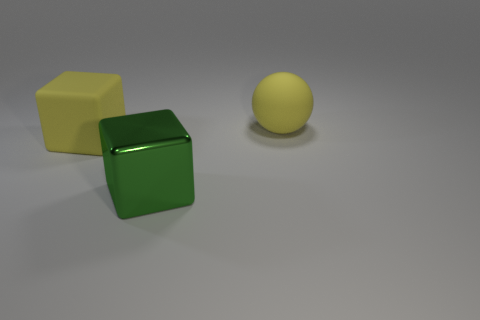There is another object that is the same shape as the green shiny thing; what material is it?
Provide a succinct answer. Rubber. Does the thing that is right of the large green object have the same color as the rubber object in front of the yellow rubber sphere?
Keep it short and to the point. Yes. Is there a metallic block that has the same size as the green shiny thing?
Your answer should be very brief. No. There is a large thing that is to the left of the yellow matte ball and behind the green shiny cube; what is its material?
Give a very brief answer. Rubber. What number of metallic objects are large brown blocks or yellow spheres?
Keep it short and to the point. 0. There is a large yellow object that is made of the same material as the ball; what shape is it?
Ensure brevity in your answer.  Cube. What number of large objects are both on the left side of the large rubber ball and behind the large green cube?
Your answer should be compact. 1. Is there anything else that has the same shape as the shiny thing?
Make the answer very short. Yes. What is the size of the yellow matte object that is in front of the ball?
Keep it short and to the point. Large. What number of other objects are the same color as the matte sphere?
Make the answer very short. 1. 